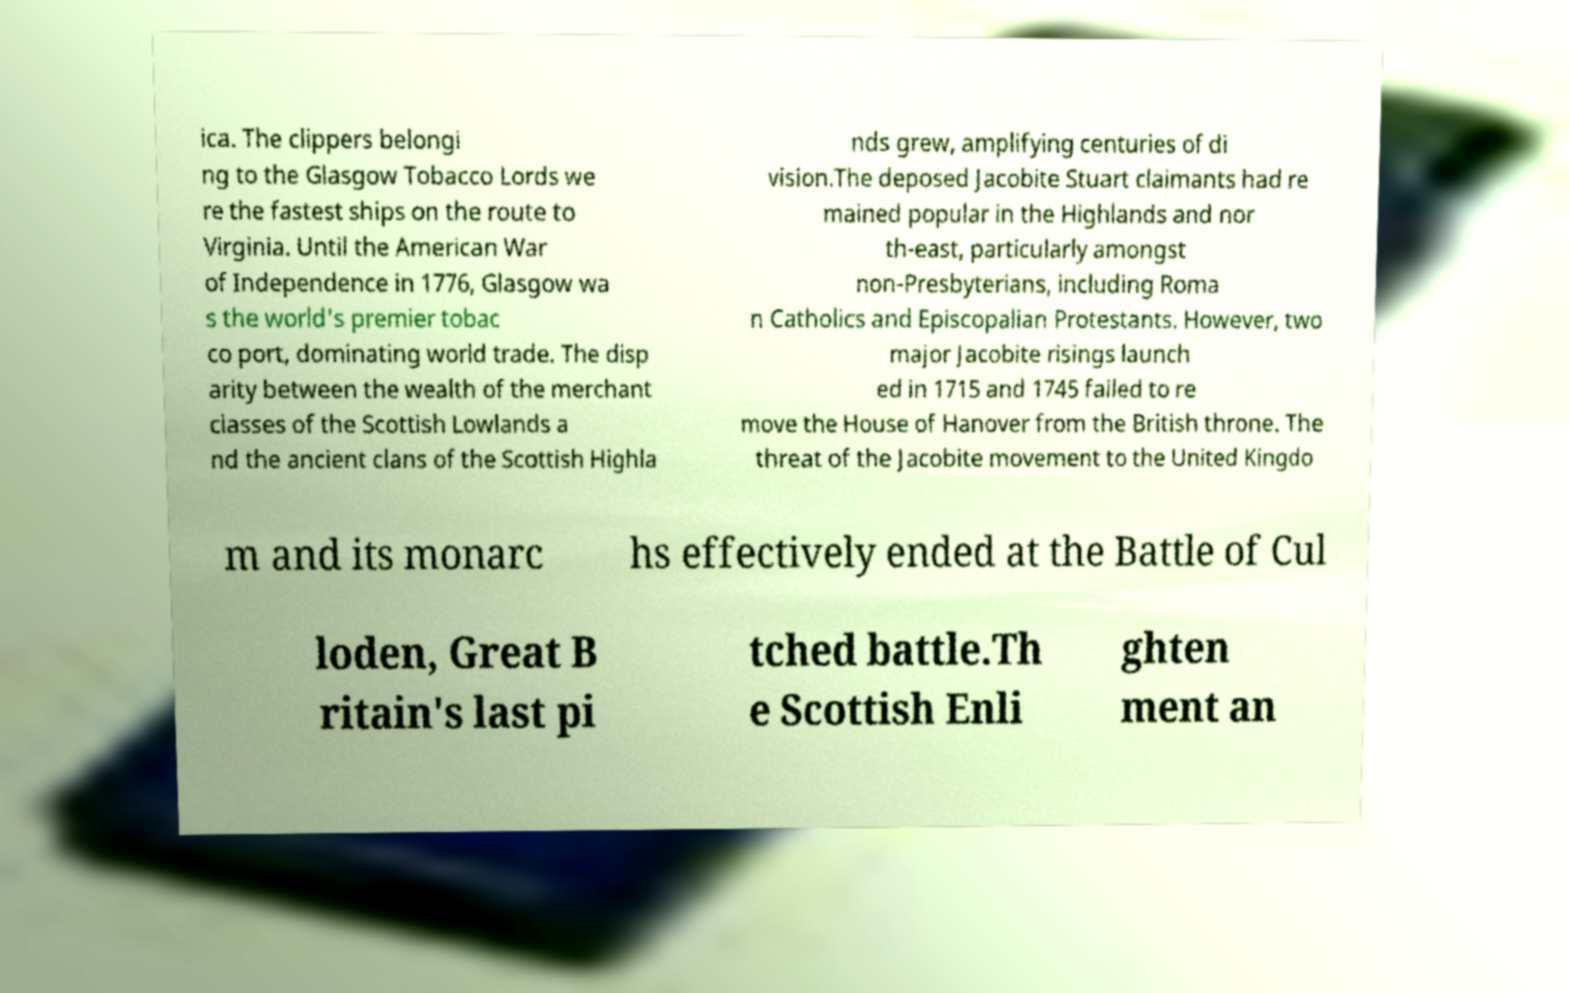What messages or text are displayed in this image? I need them in a readable, typed format. ica. The clippers belongi ng to the Glasgow Tobacco Lords we re the fastest ships on the route to Virginia. Until the American War of Independence in 1776, Glasgow wa s the world's premier tobac co port, dominating world trade. The disp arity between the wealth of the merchant classes of the Scottish Lowlands a nd the ancient clans of the Scottish Highla nds grew, amplifying centuries of di vision.The deposed Jacobite Stuart claimants had re mained popular in the Highlands and nor th-east, particularly amongst non-Presbyterians, including Roma n Catholics and Episcopalian Protestants. However, two major Jacobite risings launch ed in 1715 and 1745 failed to re move the House of Hanover from the British throne. The threat of the Jacobite movement to the United Kingdo m and its monarc hs effectively ended at the Battle of Cul loden, Great B ritain's last pi tched battle.Th e Scottish Enli ghten ment an 